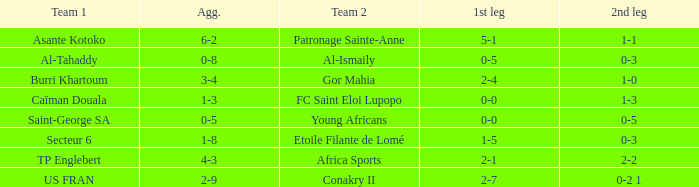Which teams had a total score of 3-4? Burri Khartoum. 